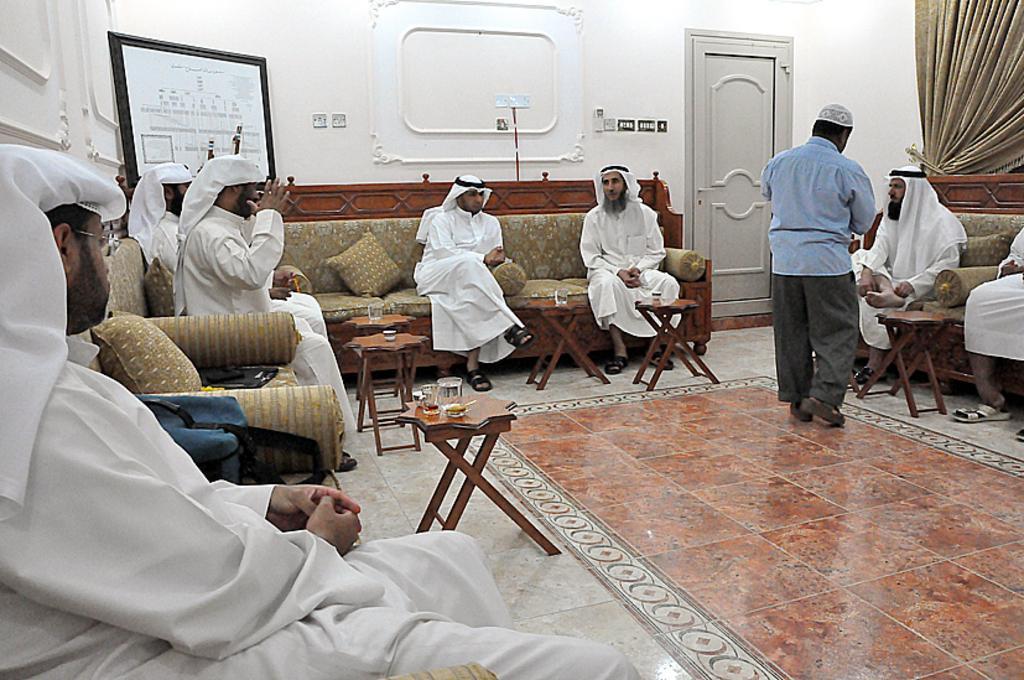Please provide a concise description of this image. In this picture we can see some people sitting on sofa with pillows beside to them and here person in middle standing and serving them and in front of them there is table and on table we can see glasses and in background we can see wall, doors, curtains, frames. 